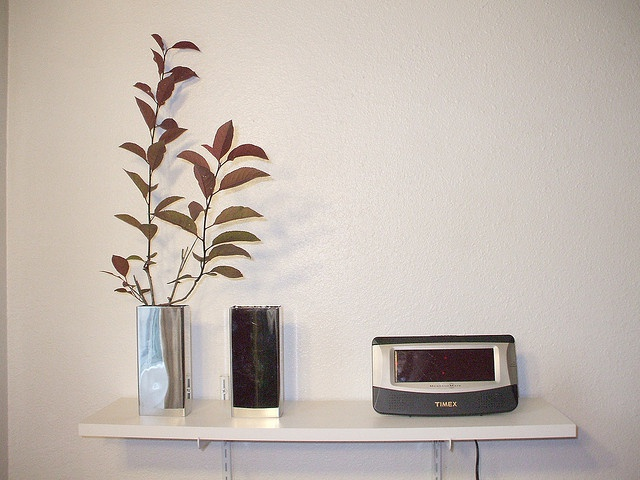Describe the objects in this image and their specific colors. I can see clock in gray, black, darkgray, and lightgray tones, vase in gray, black, darkgray, and ivory tones, and vase in gray, darkgray, lightgray, and lightblue tones in this image. 